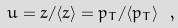Convert formula to latex. <formula><loc_0><loc_0><loc_500><loc_500>u = z / \langle z \rangle = p _ { T } / \langle p _ { T } \rangle \ ,</formula> 